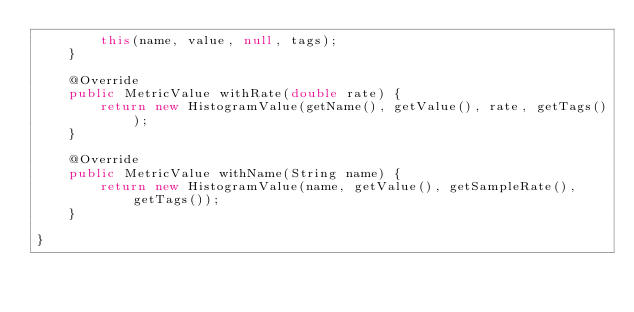Convert code to text. <code><loc_0><loc_0><loc_500><loc_500><_Java_>		this(name, value, null, tags);
	}

	@Override
	public MetricValue withRate(double rate) {
		return new HistogramValue(getName(), getValue(), rate, getTags());
	}

	@Override
	public MetricValue withName(String name) {
		return new HistogramValue(name, getValue(), getSampleRate(), getTags());
	}

}
</code> 